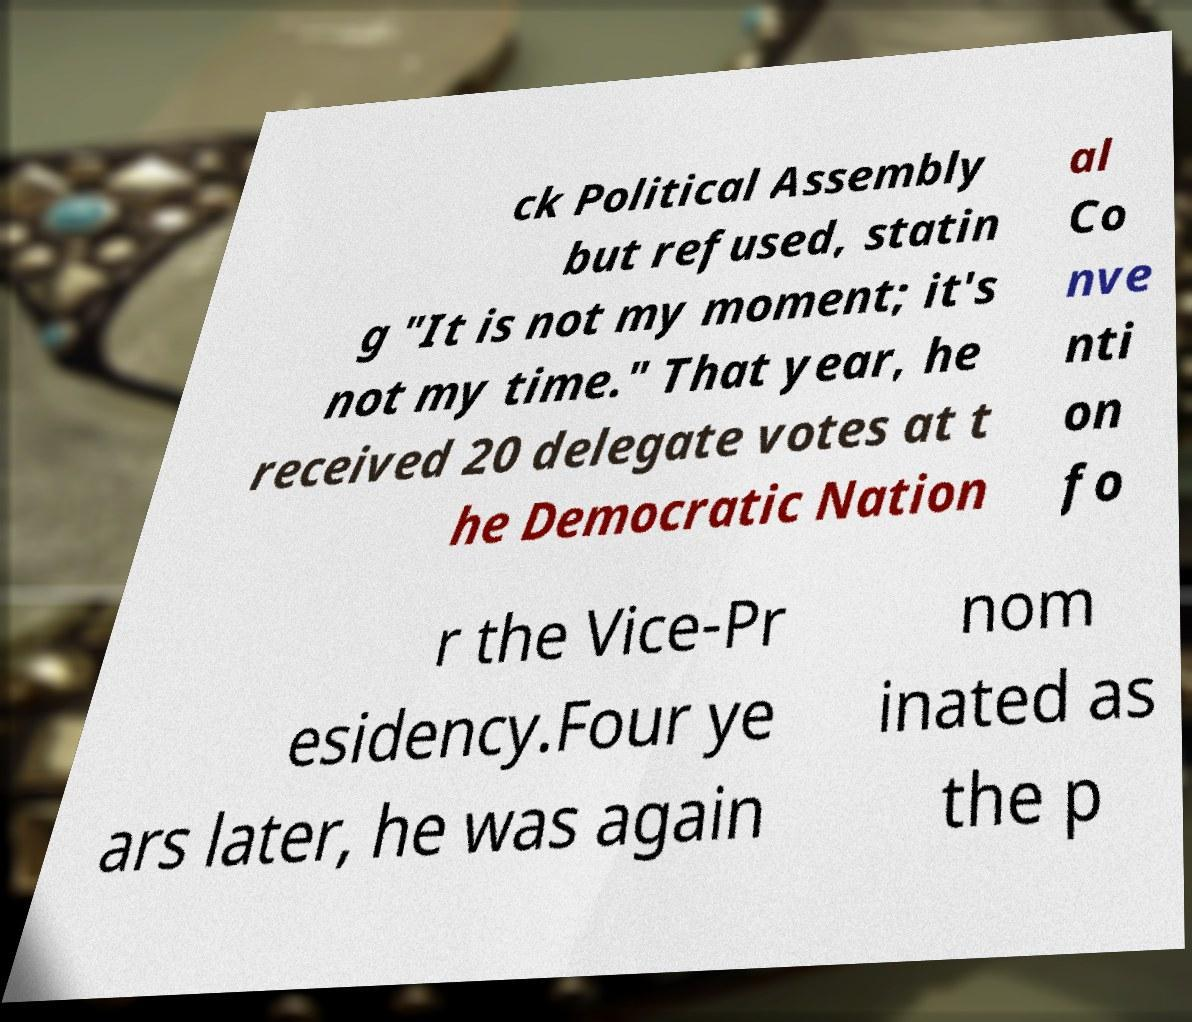What messages or text are displayed in this image? I need them in a readable, typed format. ck Political Assembly but refused, statin g "It is not my moment; it's not my time." That year, he received 20 delegate votes at t he Democratic Nation al Co nve nti on fo r the Vice-Pr esidency.Four ye ars later, he was again nom inated as the p 